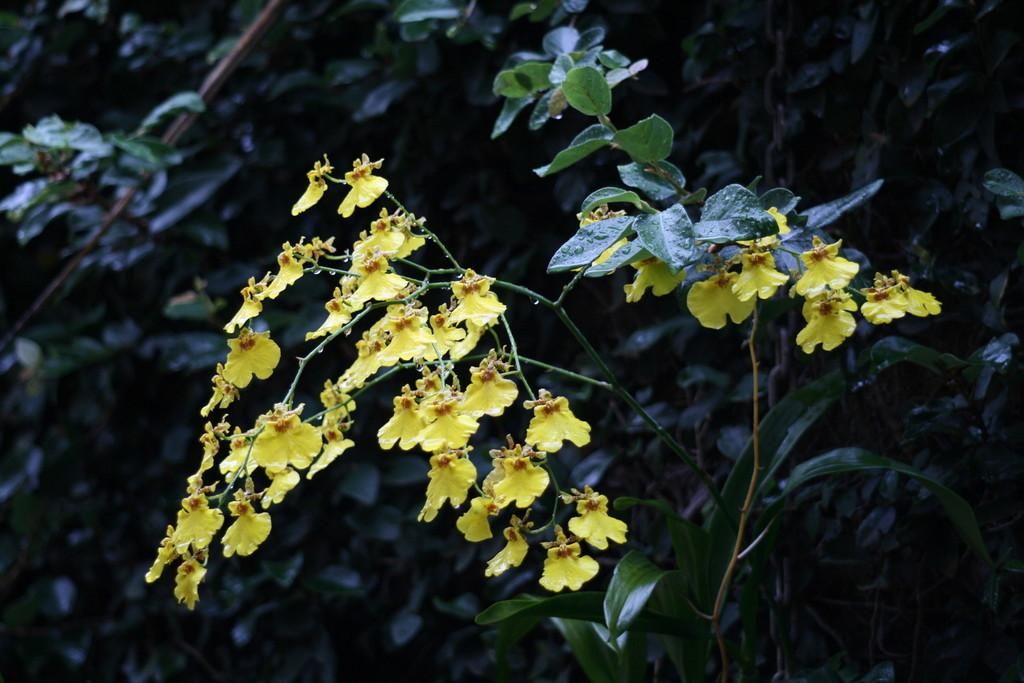What type of plants can be seen in the image? There are flowers and trees in the image. Can you describe the setting where the plants are located? The image features a natural setting with both flowers and trees. What type of lettuce is being served for dinner in the image? There is no lettuce or dinner present in the image; it features flowers and trees in a natural setting. 